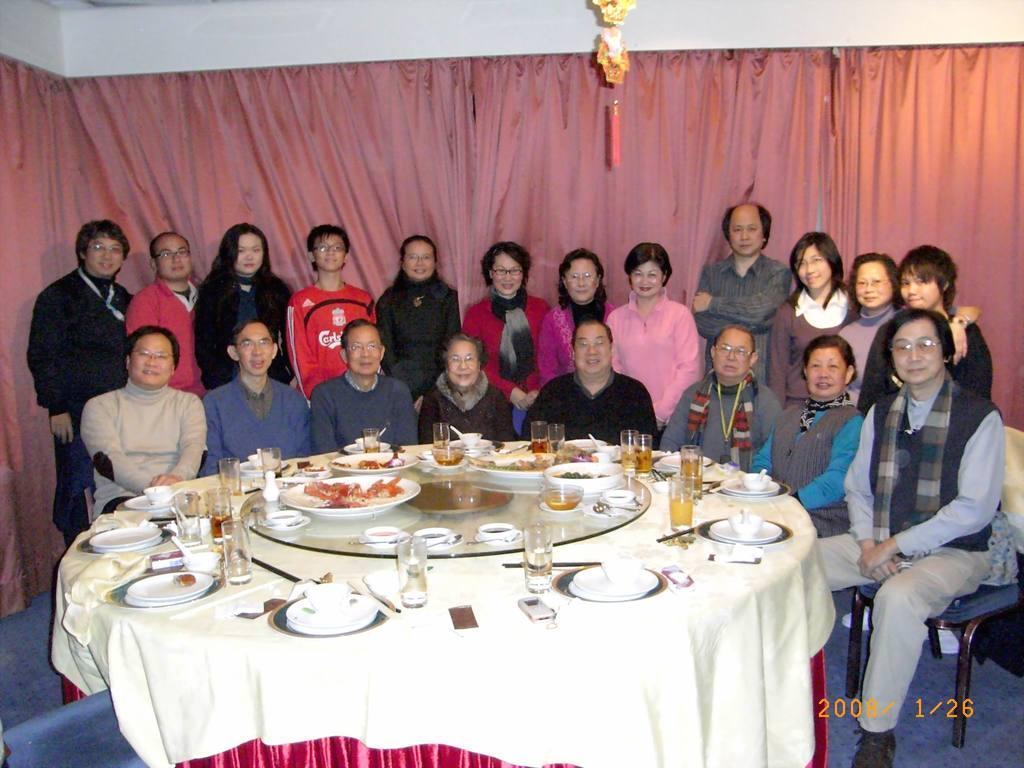Please provide a concise description of this image. In this image, there are few people sitting and few people standing. This is a table, which is covered with a cloth. I can see the glasses, plates, bowls, mobile phones and few other things on it. These are the curtains hanging to a hanger. At the top of the image, that looks like an object, which is hanging. At the bottom of the image, I can see the watermark. I think this is the carpet on the floor. 